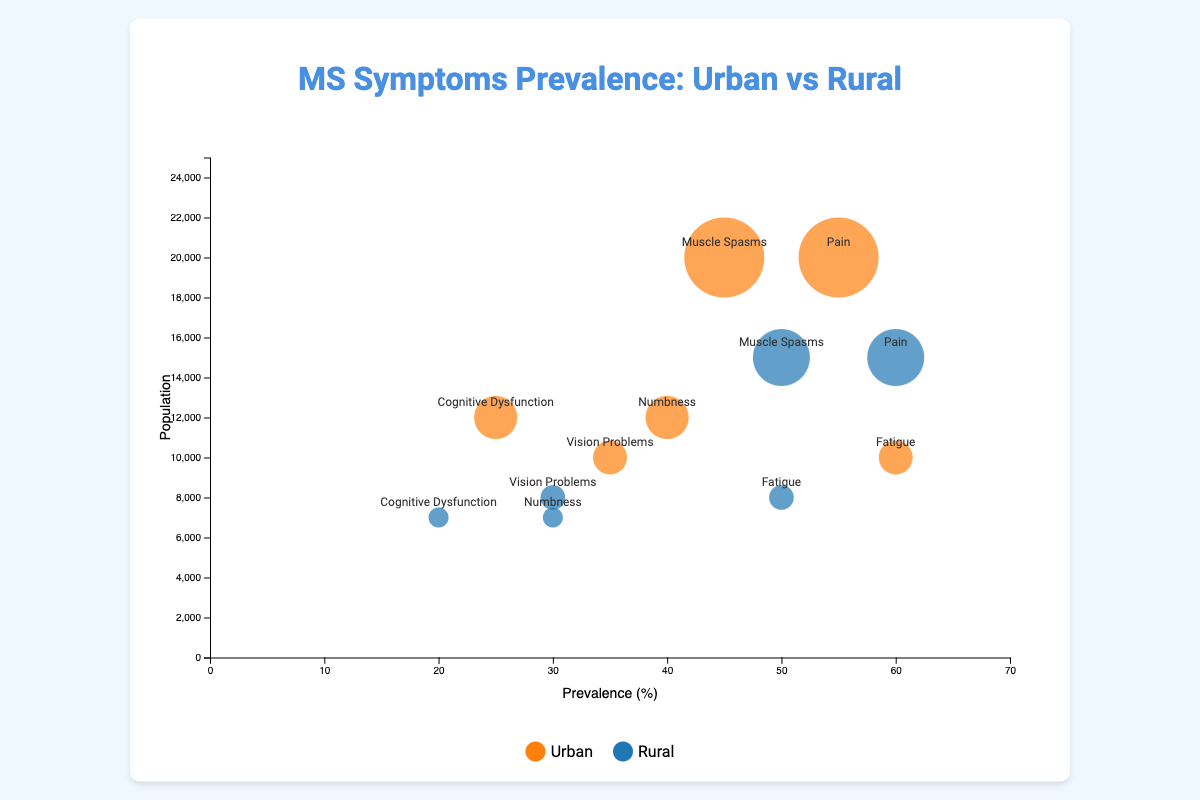What is the title of the chart? The title is prominently displayed at the top of the chart, indicating the main subject of the visual representation.
Answer: MS Symptoms Prevalence: Urban vs Rural How many regions are represented in the chart? The chart shows data points that specifically mention the "Region" field. These regions are North America, Europe, and Asia.
Answer: 3 Which region and setting has the highest prevalence of pain? By examining the data points for pain across different regions and settings, Asia (Rural) has a prevalence of 60%, which is the highest for pain.
Answer: Asia (Rural) Compare the prevalence of fatigue in urban and rural areas in North America. Which setting has a higher prevalence? Look for the data points for fatigue in both urban and rural settings in North America. Urban has a prevalence of 60%, while Rural has 50%. Urban is higher.
Answer: Urban What is the combined population of all rural settings represented in the chart? Sum the populations of all the rural settings: 8000 (North America) + 7000 (Europe) + 15000 (Asia) + 8000 (North America) + 7000 (Europe) + 15000 (Asia) = 60000
Answer: 60000 Which symptom has the highest prevalence in Europe? The symptoms in Europe are numbness (40% Urban, 30% Rural) and cognitive dysfunction (25% Urban, 20% Rural). Numbness in Urban (40%) is the highest.
Answer: Numbness (Urban) Describe the relationship between prevalence and population size in the figure. Observing the chart, there doesn't seem to be a direct correlation between prevalence and population size as different symptoms with varying prevalence are associated with different population sizes across regions.
Answer: No direct correlation In which region and setting is the lowest prevalence of cognitive dysfunction observed? Cognitive dysfunction is only noted in Europe. The rural setting has a prevalence of 20%, which is lower than the urban setting's 25%.
Answer: Europe (Rural) Which symptom is represented by the largest bubble? The largest bubble corresponds to the data point with the highest population. The largest population is 20000 for urban areas in Asia, which is represented by Muscle Spasms (Urban).
Answer: Muscle Spasms (Urban) How does the prevalence of vision problems in rural North America compare to urban North America? The prevalence of vision problems in rural North America is 30%, while in urban North America it is 35%. Vision problems are slightly more prevalent in urban areas.
Answer: Urban (35%) > Rural (30%) 